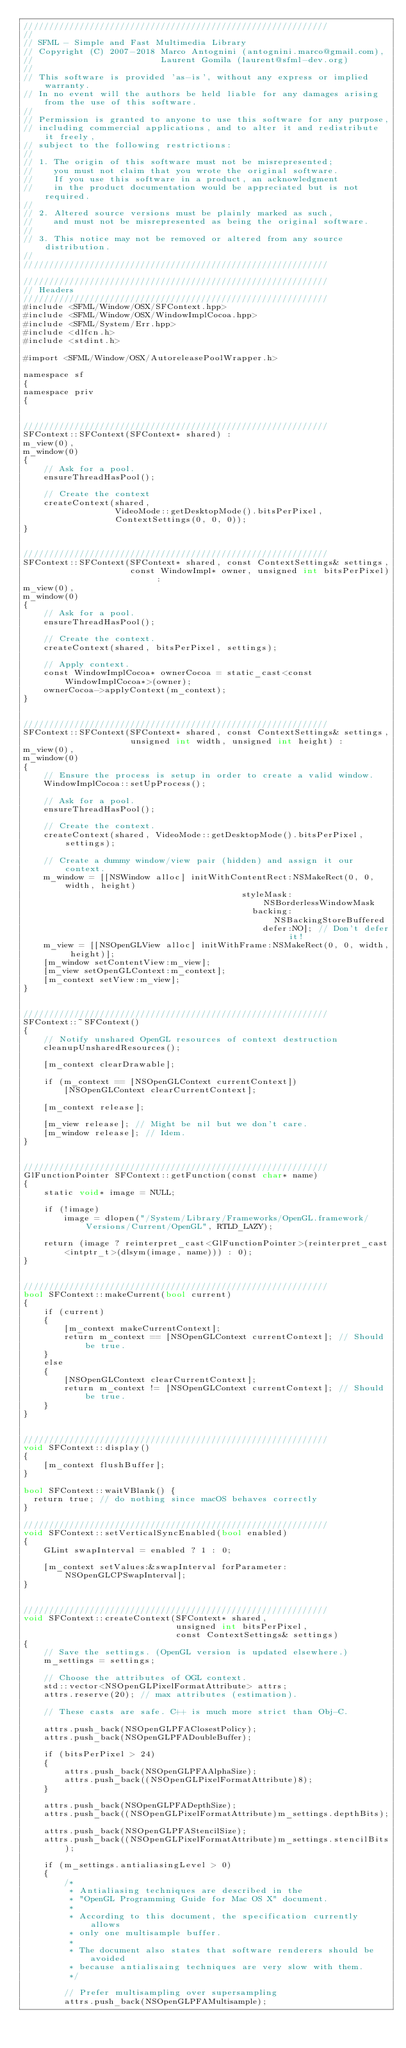Convert code to text. <code><loc_0><loc_0><loc_500><loc_500><_ObjectiveC_>////////////////////////////////////////////////////////////
//
// SFML - Simple and Fast Multimedia Library
// Copyright (C) 2007-2018 Marco Antognini (antognini.marco@gmail.com),
//                         Laurent Gomila (laurent@sfml-dev.org)
//
// This software is provided 'as-is', without any express or implied warranty.
// In no event will the authors be held liable for any damages arising from the use of this software.
//
// Permission is granted to anyone to use this software for any purpose,
// including commercial applications, and to alter it and redistribute it freely,
// subject to the following restrictions:
//
// 1. The origin of this software must not be misrepresented;
//    you must not claim that you wrote the original software.
//    If you use this software in a product, an acknowledgment
//    in the product documentation would be appreciated but is not required.
//
// 2. Altered source versions must be plainly marked as such,
//    and must not be misrepresented as being the original software.
//
// 3. This notice may not be removed or altered from any source distribution.
//
////////////////////////////////////////////////////////////

////////////////////////////////////////////////////////////
// Headers
////////////////////////////////////////////////////////////
#include <SFML/Window/OSX/SFContext.hpp>
#include <SFML/Window/OSX/WindowImplCocoa.hpp>
#include <SFML/System/Err.hpp>
#include <dlfcn.h>
#include <stdint.h>

#import <SFML/Window/OSX/AutoreleasePoolWrapper.h>

namespace sf
{
namespace priv
{


////////////////////////////////////////////////////////////
SFContext::SFContext(SFContext* shared) :
m_view(0),
m_window(0)
{
    // Ask for a pool.
    ensureThreadHasPool();

    // Create the context
    createContext(shared,
                  VideoMode::getDesktopMode().bitsPerPixel,
                  ContextSettings(0, 0, 0));
}


////////////////////////////////////////////////////////////
SFContext::SFContext(SFContext* shared, const ContextSettings& settings,
                     const WindowImpl* owner, unsigned int bitsPerPixel) :
m_view(0),
m_window(0)
{
    // Ask for a pool.
    ensureThreadHasPool();

    // Create the context.
    createContext(shared, bitsPerPixel, settings);

    // Apply context.
    const WindowImplCocoa* ownerCocoa = static_cast<const WindowImplCocoa*>(owner);
    ownerCocoa->applyContext(m_context);
}


////////////////////////////////////////////////////////////
SFContext::SFContext(SFContext* shared, const ContextSettings& settings,
                     unsigned int width, unsigned int height) :
m_view(0),
m_window(0)
{
    // Ensure the process is setup in order to create a valid window.
    WindowImplCocoa::setUpProcess();

    // Ask for a pool.
    ensureThreadHasPool();

    // Create the context.
    createContext(shared, VideoMode::getDesktopMode().bitsPerPixel, settings);

    // Create a dummy window/view pair (hidden) and assign it our context.
    m_window = [[NSWindow alloc] initWithContentRect:NSMakeRect(0, 0, width, height)
                                           styleMask:NSBorderlessWindowMask
                                             backing:NSBackingStoreBuffered
                                               defer:NO]; // Don't defer it!
    m_view = [[NSOpenGLView alloc] initWithFrame:NSMakeRect(0, 0, width, height)];
    [m_window setContentView:m_view];
    [m_view setOpenGLContext:m_context];
    [m_context setView:m_view];
}


////////////////////////////////////////////////////////////
SFContext::~SFContext()
{
    // Notify unshared OpenGL resources of context destruction
    cleanupUnsharedResources();

    [m_context clearDrawable];

    if (m_context == [NSOpenGLContext currentContext])
        [NSOpenGLContext clearCurrentContext];

    [m_context release];

    [m_view release]; // Might be nil but we don't care.
    [m_window release]; // Idem.
}


////////////////////////////////////////////////////////////
GlFunctionPointer SFContext::getFunction(const char* name)
{
    static void* image = NULL;

    if (!image)
        image = dlopen("/System/Library/Frameworks/OpenGL.framework/Versions/Current/OpenGL", RTLD_LAZY);

    return (image ? reinterpret_cast<GlFunctionPointer>(reinterpret_cast<intptr_t>(dlsym(image, name))) : 0);
}


////////////////////////////////////////////////////////////
bool SFContext::makeCurrent(bool current)
{
    if (current)
    {
        [m_context makeCurrentContext];
        return m_context == [NSOpenGLContext currentContext]; // Should be true.
    }
    else
    {
        [NSOpenGLContext clearCurrentContext];
        return m_context != [NSOpenGLContext currentContext]; // Should be true.
    }
}


////////////////////////////////////////////////////////////
void SFContext::display()
{
    [m_context flushBuffer];
}

bool SFContext::waitVBlank() {
  return true; // do nothing since macOS behaves correctly
}

////////////////////////////////////////////////////////////
void SFContext::setVerticalSyncEnabled(bool enabled)
{
    GLint swapInterval = enabled ? 1 : 0;

    [m_context setValues:&swapInterval forParameter:NSOpenGLCPSwapInterval];
}


////////////////////////////////////////////////////////////
void SFContext::createContext(SFContext* shared,
                              unsigned int bitsPerPixel,
                              const ContextSettings& settings)
{
    // Save the settings. (OpenGL version is updated elsewhere.)
    m_settings = settings;

    // Choose the attributes of OGL context.
    std::vector<NSOpenGLPixelFormatAttribute> attrs;
    attrs.reserve(20); // max attributes (estimation).

    // These casts are safe. C++ is much more strict than Obj-C.

    attrs.push_back(NSOpenGLPFAClosestPolicy);
    attrs.push_back(NSOpenGLPFADoubleBuffer);

    if (bitsPerPixel > 24)
    {
        attrs.push_back(NSOpenGLPFAAlphaSize);
        attrs.push_back((NSOpenGLPixelFormatAttribute)8);
    }

    attrs.push_back(NSOpenGLPFADepthSize);
    attrs.push_back((NSOpenGLPixelFormatAttribute)m_settings.depthBits);

    attrs.push_back(NSOpenGLPFAStencilSize);
    attrs.push_back((NSOpenGLPixelFormatAttribute)m_settings.stencilBits);

    if (m_settings.antialiasingLevel > 0)
    {
        /*
         * Antialiasing techniques are described in the
         * "OpenGL Programming Guide for Mac OS X" document.
         *
         * According to this document, the specification currently allows
         * only one multisample buffer.
         *
         * The document also states that software renderers should be avoided
         * because antialisaing techniques are very slow with them.
         */

        // Prefer multisampling over supersampling
        attrs.push_back(NSOpenGLPFAMultisample);
</code> 